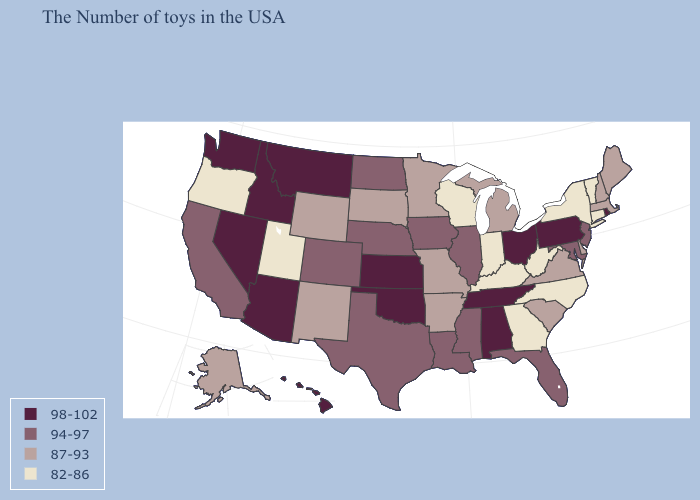Among the states that border Michigan , does Wisconsin have the highest value?
Quick response, please. No. What is the highest value in states that border Missouri?
Give a very brief answer. 98-102. Which states hav the highest value in the Northeast?
Answer briefly. Rhode Island, Pennsylvania. What is the value of Louisiana?
Quick response, please. 94-97. Does Pennsylvania have the same value as Minnesota?
Quick response, please. No. What is the highest value in the USA?
Write a very short answer. 98-102. What is the highest value in states that border North Carolina?
Short answer required. 98-102. Does Washington have a higher value than West Virginia?
Keep it brief. Yes. How many symbols are there in the legend?
Answer briefly. 4. Name the states that have a value in the range 98-102?
Write a very short answer. Rhode Island, Pennsylvania, Ohio, Alabama, Tennessee, Kansas, Oklahoma, Montana, Arizona, Idaho, Nevada, Washington, Hawaii. Which states hav the highest value in the Northeast?
Keep it brief. Rhode Island, Pennsylvania. What is the value of Iowa?
Be succinct. 94-97. What is the highest value in the USA?
Answer briefly. 98-102. What is the highest value in the MidWest ?
Concise answer only. 98-102. Does the map have missing data?
Quick response, please. No. 